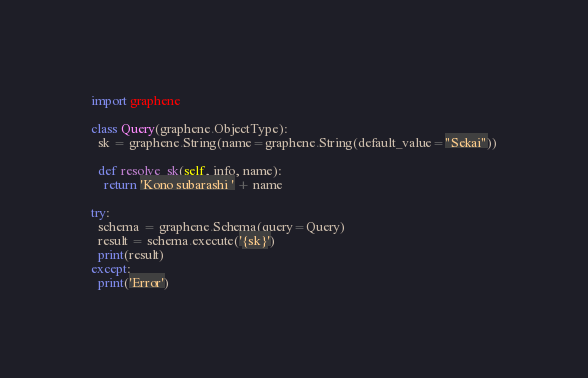Convert code to text. <code><loc_0><loc_0><loc_500><loc_500><_Python_>import graphene

class Query(graphene.ObjectType):
  sk = graphene.String(name=graphene.String(default_value="Sekai"))

  def resolve_sk(self, info, name):
    return 'Kono subarashi ' + name

try:
  schema = graphene.Schema(query=Query)
  result = schema.execute('{sk}')
  print(result)
except:
  print('Error')</code> 